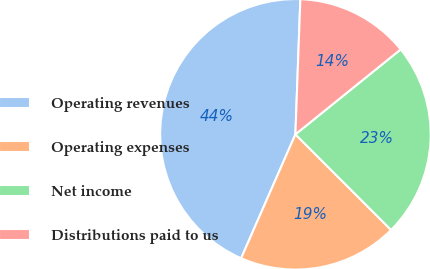Convert chart. <chart><loc_0><loc_0><loc_500><loc_500><pie_chart><fcel>Operating revenues<fcel>Operating expenses<fcel>Net income<fcel>Distributions paid to us<nl><fcel>44.01%<fcel>19.07%<fcel>23.3%<fcel>13.61%<nl></chart> 